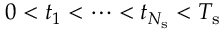Convert formula to latex. <formula><loc_0><loc_0><loc_500><loc_500>0 < t _ { 1 } < \cdots < t _ { N _ { s } } < T _ { s }</formula> 